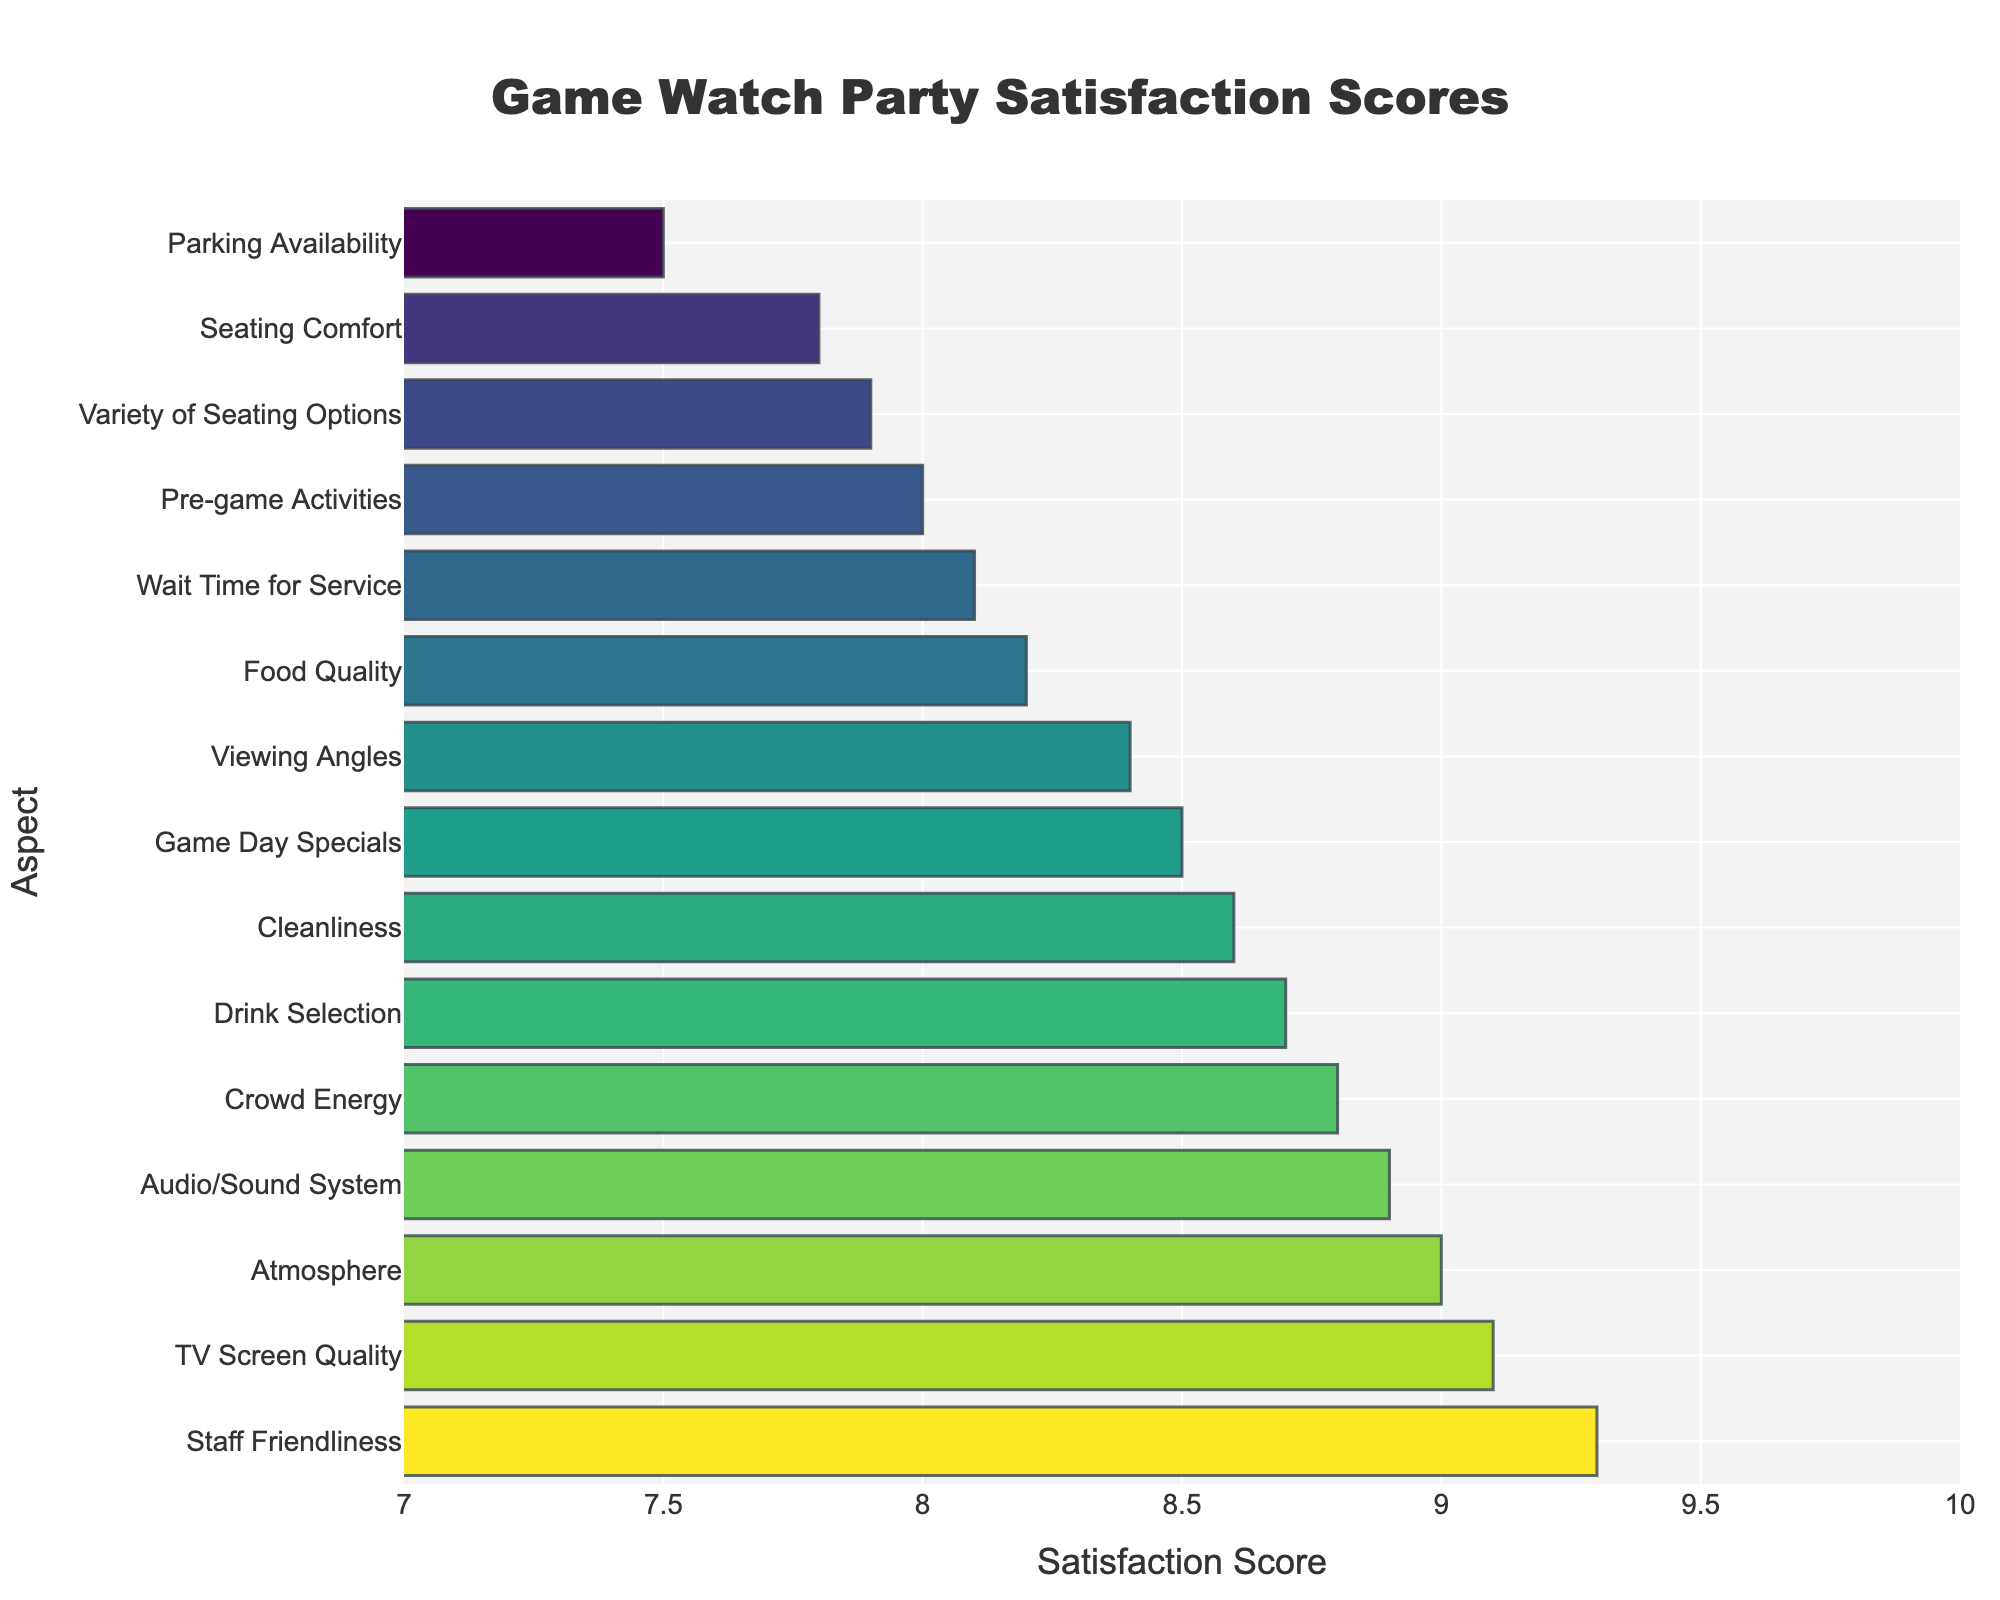Which aspect has the highest satisfaction score? The bar chart shows different satisfaction scores for various aspects. The highest bar represents the aspect with the top score.
Answer: Staff Friendliness Which aspect has the lowest satisfaction score? By examining the shortest bars, the aspect with the lowest score can be identified.
Answer: Parking Availability What is the score difference between 'TV Screen Quality' and 'Seating Comfort'? Find the scores for 'TV Screen Quality' (9.1) and 'Seating Comfort' (7.8) and compute the difference (9.1 - 7.8).
Answer: 1.3 How many aspects have a satisfaction score greater than 8.5? Count the bars that extend beyond the 8.5 marks on the x-axis. The aspects are 'Drink Selection', 'TV Screen Quality', 'Audio/Sound System', 'Staff Friendliness', 'Atmosphere', 'Game Day Specials', 'Crowd Energy', 'Cleanliness', and 'Viewing Angles'.
Answer: 10 What is the average satisfaction score of 'Food Quality', 'Cleanliness', and 'Pre-game Activities'? Sum the scores of the three aspects (8.2 + 8.6 + 8.0) and then divide by 3.
Answer: 8.27 Is 'Wait Time for Service' better or worse than 'Variety of Seating Options'? Compare the scores of 'Wait Time for Service' (8.1) and 'Variety of Seating Options' (7.9). Since 8.1 > 7.9, 'Wait Time for Service' is better.
Answer: Better Which aspects have a satisfaction score exactly 8.5? Identify the bars ending exactly at the 8.5 marks on the x-axis.
Answer: Game Day Specials What is the total satisfaction score for the aspects related to seating (Seating Comfort, Variety of Seating Options, Viewing Angles)? Sum the satisfaction scores for 'Seating Comfort' (7.8), 'Variety of Seating Options' (7.9), and 'Viewing Angles' (8.4).
Answer: 24.1 Which aspect falls between the satisfaction scores of 8.3 and 8.5? Find the bars that have their scores within the specified range (i.e., between 8.3 and 8.5).
Answer: Viewing Angles 